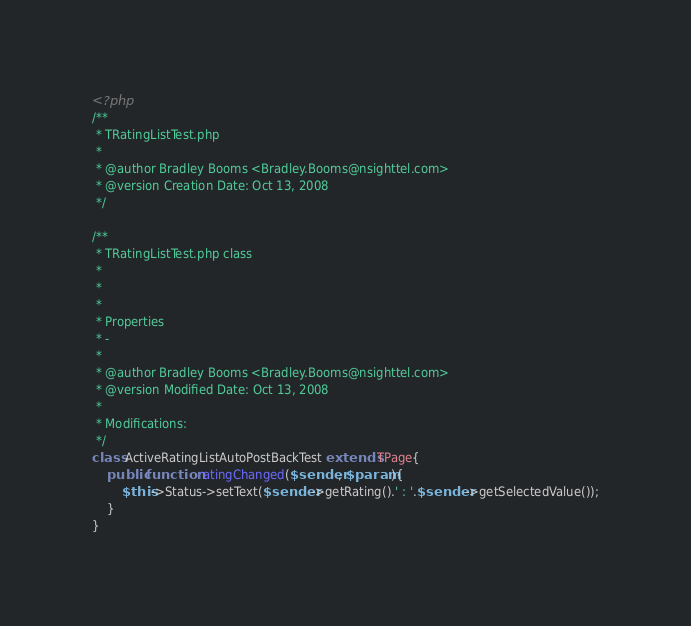<code> <loc_0><loc_0><loc_500><loc_500><_PHP_><?php
/**
 * TRatingListTest.php
 * 
 * @author Bradley Booms <Bradley.Booms@nsighttel.com>
 * @version Creation Date: Oct 13, 2008
 */

/**
 * TRatingListTest.php class
 * 
 * 
 * 
 * Properties
 * -
 * 
 * @author Bradley Booms <Bradley.Booms@nsighttel.com>
 * @version Modified Date: Oct 13, 2008
 * 
 * Modifications:
 */
class ActiveRatingListAutoPostBackTest extends TPage{
	public function ratingChanged($sender, $param){
		$this->Status->setText($sender->getRating().' : '.$sender->getSelectedValue());
	}
}</code> 